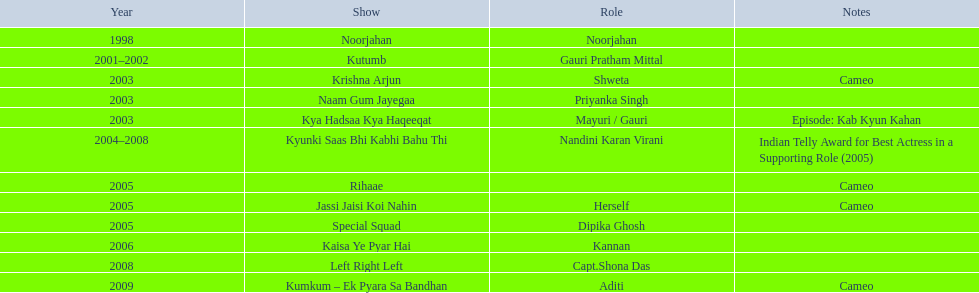What is the total number of tv series in which gauri tejwani has appeared, either as a star or in a cameo role? 11. 